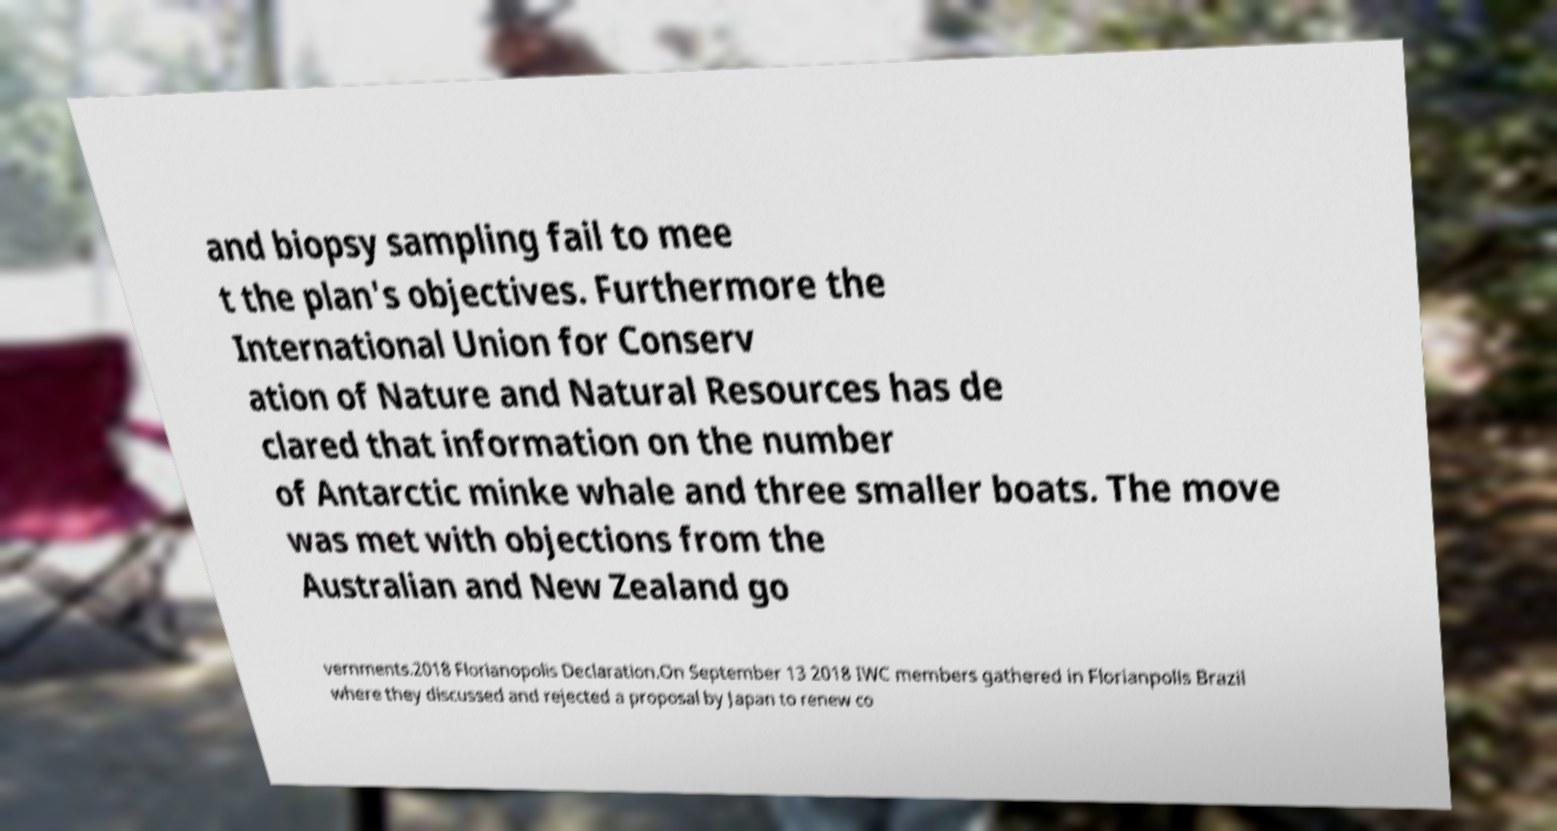Please identify and transcribe the text found in this image. and biopsy sampling fail to mee t the plan's objectives. Furthermore the International Union for Conserv ation of Nature and Natural Resources has de clared that information on the number of Antarctic minke whale and three smaller boats. The move was met with objections from the Australian and New Zealand go vernments.2018 Florianopolis Declaration.On September 13 2018 IWC members gathered in Florianpolis Brazil where they discussed and rejected a proposal by Japan to renew co 